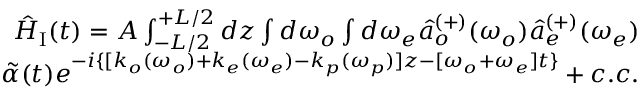Convert formula to latex. <formula><loc_0><loc_0><loc_500><loc_500>\begin{array} { r } { \hat { H } _ { I } ( t ) = A \int _ { - L / 2 } ^ { + L / 2 } d z \int d \omega _ { o } \int d \omega _ { e } \hat { a } _ { o } ^ { ( + ) } ( \omega _ { o } ) \hat { a } _ { e } ^ { ( + ) } ( \omega _ { e } ) } \\ { \tilde { \alpha } ( t ) e ^ { - i \{ [ k _ { o } ( \omega _ { o } ) + k _ { e } ( \omega _ { e } ) - k _ { p } ( \omega _ { p } ) ] z - [ \omega _ { o } + \omega _ { e } ] t \} } + c . c . } \end{array}</formula> 